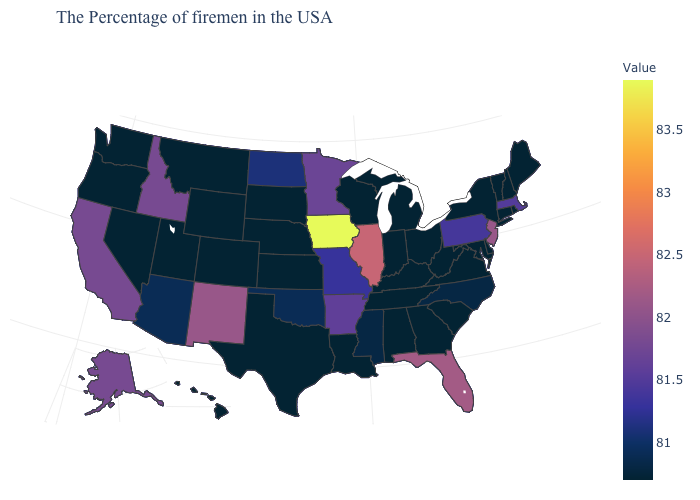Does New Mexico have the highest value in the West?
Give a very brief answer. Yes. Among the states that border Iowa , does Minnesota have the lowest value?
Write a very short answer. No. Does Oklahoma have a lower value than New Mexico?
Short answer required. Yes. Which states hav the highest value in the MidWest?
Write a very short answer. Iowa. Which states have the lowest value in the USA?
Quick response, please. Maine, Rhode Island, New Hampshire, Vermont, Connecticut, New York, Delaware, Maryland, Virginia, South Carolina, West Virginia, Ohio, Georgia, Michigan, Kentucky, Indiana, Alabama, Tennessee, Wisconsin, Louisiana, Kansas, Nebraska, Texas, South Dakota, Wyoming, Colorado, Utah, Montana, Nevada, Washington, Oregon, Hawaii. Which states have the lowest value in the South?
Quick response, please. Delaware, Maryland, Virginia, South Carolina, West Virginia, Georgia, Kentucky, Alabama, Tennessee, Louisiana, Texas. Is the legend a continuous bar?
Be succinct. Yes. Does Florida have a higher value than Iowa?
Concise answer only. No. 